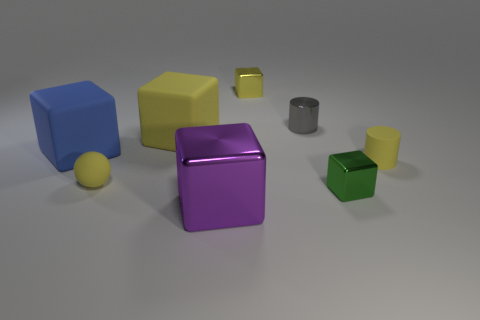What objects in the scene can reflect light well? The large purple cube appears to have a highly reflective, metallic surface that would reflect light well, along with the smaller metallic cylinder towards the center. 